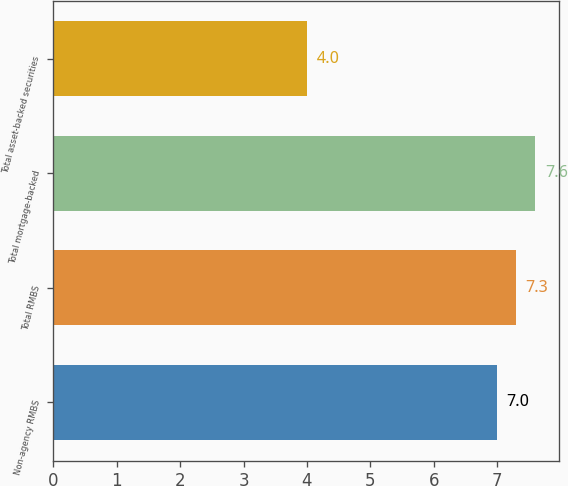Convert chart to OTSL. <chart><loc_0><loc_0><loc_500><loc_500><bar_chart><fcel>Non-agency RMBS<fcel>Total RMBS<fcel>Total mortgage-backed<fcel>Total asset-backed securities<nl><fcel>7<fcel>7.3<fcel>7.6<fcel>4<nl></chart> 